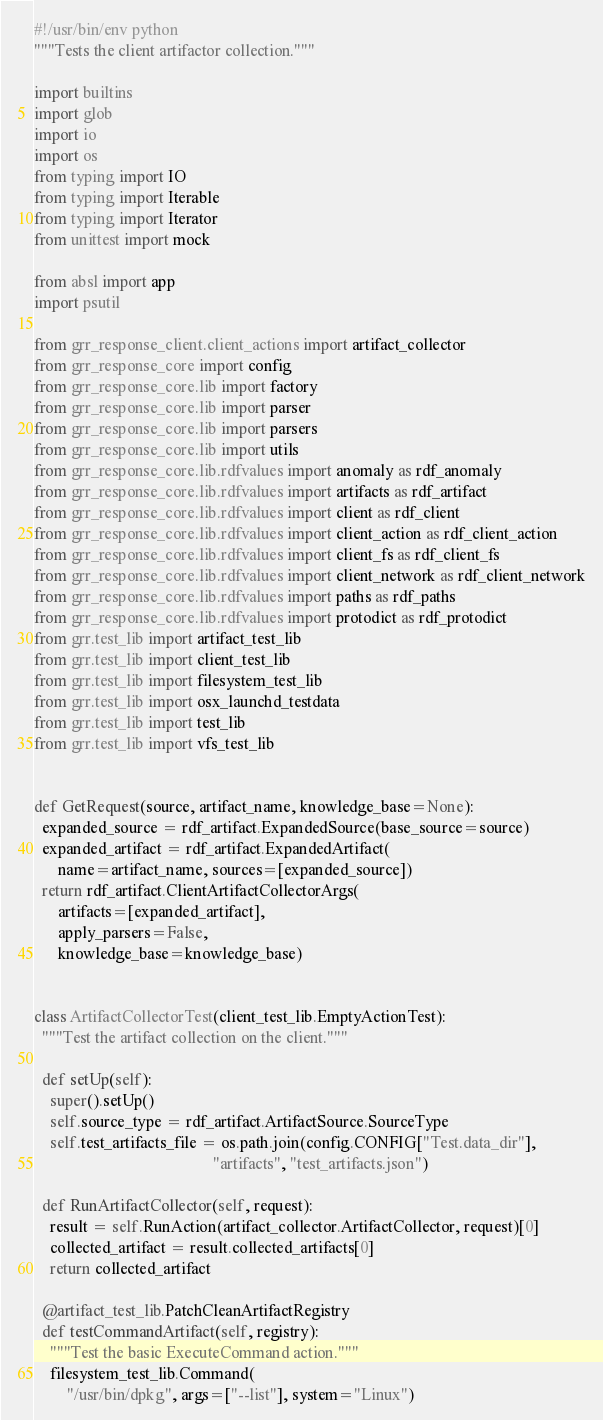<code> <loc_0><loc_0><loc_500><loc_500><_Python_>#!/usr/bin/env python
"""Tests the client artifactor collection."""

import builtins
import glob
import io
import os
from typing import IO
from typing import Iterable
from typing import Iterator
from unittest import mock

from absl import app
import psutil

from grr_response_client.client_actions import artifact_collector
from grr_response_core import config
from grr_response_core.lib import factory
from grr_response_core.lib import parser
from grr_response_core.lib import parsers
from grr_response_core.lib import utils
from grr_response_core.lib.rdfvalues import anomaly as rdf_anomaly
from grr_response_core.lib.rdfvalues import artifacts as rdf_artifact
from grr_response_core.lib.rdfvalues import client as rdf_client
from grr_response_core.lib.rdfvalues import client_action as rdf_client_action
from grr_response_core.lib.rdfvalues import client_fs as rdf_client_fs
from grr_response_core.lib.rdfvalues import client_network as rdf_client_network
from grr_response_core.lib.rdfvalues import paths as rdf_paths
from grr_response_core.lib.rdfvalues import protodict as rdf_protodict
from grr.test_lib import artifact_test_lib
from grr.test_lib import client_test_lib
from grr.test_lib import filesystem_test_lib
from grr.test_lib import osx_launchd_testdata
from grr.test_lib import test_lib
from grr.test_lib import vfs_test_lib


def GetRequest(source, artifact_name, knowledge_base=None):
  expanded_source = rdf_artifact.ExpandedSource(base_source=source)
  expanded_artifact = rdf_artifact.ExpandedArtifact(
      name=artifact_name, sources=[expanded_source])
  return rdf_artifact.ClientArtifactCollectorArgs(
      artifacts=[expanded_artifact],
      apply_parsers=False,
      knowledge_base=knowledge_base)


class ArtifactCollectorTest(client_test_lib.EmptyActionTest):
  """Test the artifact collection on the client."""

  def setUp(self):
    super().setUp()
    self.source_type = rdf_artifact.ArtifactSource.SourceType
    self.test_artifacts_file = os.path.join(config.CONFIG["Test.data_dir"],
                                            "artifacts", "test_artifacts.json")

  def RunArtifactCollector(self, request):
    result = self.RunAction(artifact_collector.ArtifactCollector, request)[0]
    collected_artifact = result.collected_artifacts[0]
    return collected_artifact

  @artifact_test_lib.PatchCleanArtifactRegistry
  def testCommandArtifact(self, registry):
    """Test the basic ExecuteCommand action."""
    filesystem_test_lib.Command(
        "/usr/bin/dpkg", args=["--list"], system="Linux")
</code> 